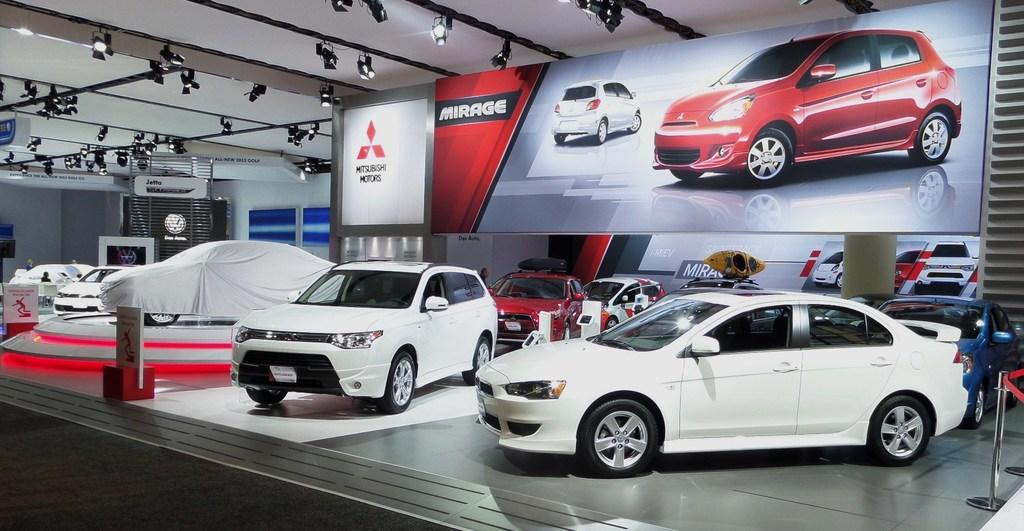What type of vehicles are present in the image? There are cars in the image. Where are the cars located? The cars are in a showroom. What additional feature can be seen in the showroom? There is a banner poster visible in the image. What might be used to illuminate the cars in the showroom? There are spotlights on the ceiling in the image. What type of glue is being used to hold the cars together in the image? There is no glue present in the image, and the cars are not being held together. 